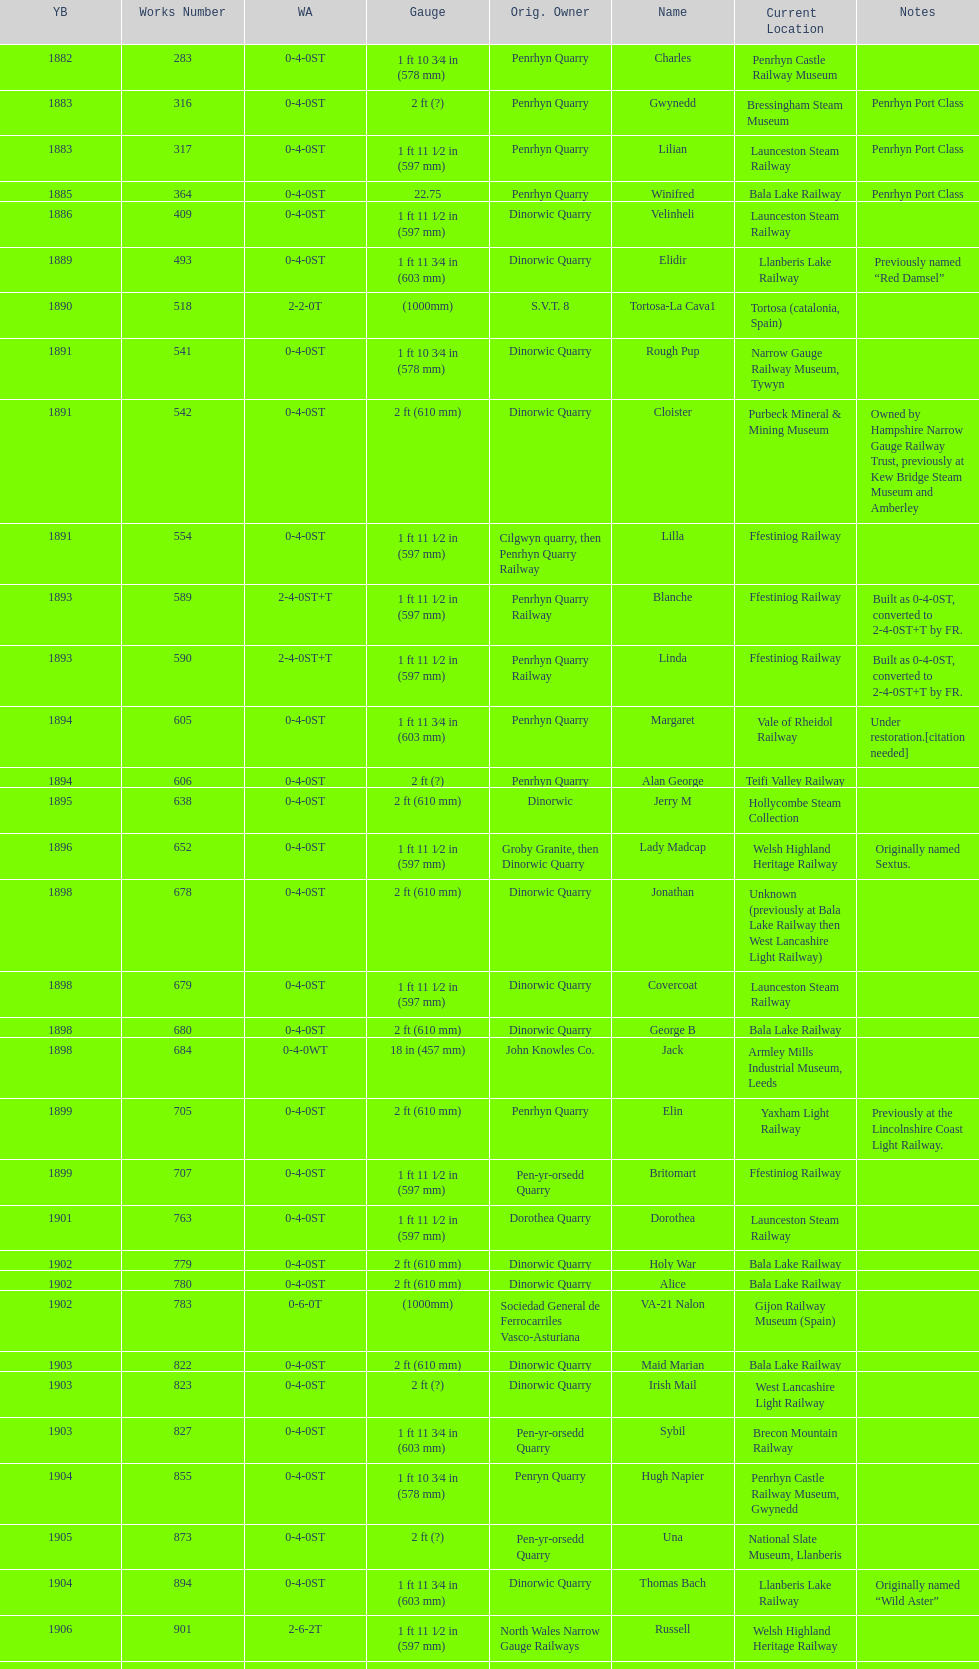Would you be able to parse every entry in this table? {'header': ['YB', 'Works Number', 'WA', 'Gauge', 'Orig. Owner', 'Name', 'Current Location', 'Notes'], 'rows': [['1882', '283', '0-4-0ST', '1\xa0ft 10\xa03⁄4\xa0in (578\xa0mm)', 'Penrhyn Quarry', 'Charles', 'Penrhyn Castle Railway Museum', ''], ['1883', '316', '0-4-0ST', '2\xa0ft (?)', 'Penrhyn Quarry', 'Gwynedd', 'Bressingham Steam Museum', 'Penrhyn Port Class'], ['1883', '317', '0-4-0ST', '1\xa0ft 11\xa01⁄2\xa0in (597\xa0mm)', 'Penrhyn Quarry', 'Lilian', 'Launceston Steam Railway', 'Penrhyn Port Class'], ['1885', '364', '0-4-0ST', '22.75', 'Penrhyn Quarry', 'Winifred', 'Bala Lake Railway', 'Penrhyn Port Class'], ['1886', '409', '0-4-0ST', '1\xa0ft 11\xa01⁄2\xa0in (597\xa0mm)', 'Dinorwic Quarry', 'Velinheli', 'Launceston Steam Railway', ''], ['1889', '493', '0-4-0ST', '1\xa0ft 11\xa03⁄4\xa0in (603\xa0mm)', 'Dinorwic Quarry', 'Elidir', 'Llanberis Lake Railway', 'Previously named “Red Damsel”'], ['1890', '518', '2-2-0T', '(1000mm)', 'S.V.T. 8', 'Tortosa-La Cava1', 'Tortosa (catalonia, Spain)', ''], ['1891', '541', '0-4-0ST', '1\xa0ft 10\xa03⁄4\xa0in (578\xa0mm)', 'Dinorwic Quarry', 'Rough Pup', 'Narrow Gauge Railway Museum, Tywyn', ''], ['1891', '542', '0-4-0ST', '2\xa0ft (610\xa0mm)', 'Dinorwic Quarry', 'Cloister', 'Purbeck Mineral & Mining Museum', 'Owned by Hampshire Narrow Gauge Railway Trust, previously at Kew Bridge Steam Museum and Amberley'], ['1891', '554', '0-4-0ST', '1\xa0ft 11\xa01⁄2\xa0in (597\xa0mm)', 'Cilgwyn quarry, then Penrhyn Quarry Railway', 'Lilla', 'Ffestiniog Railway', ''], ['1893', '589', '2-4-0ST+T', '1\xa0ft 11\xa01⁄2\xa0in (597\xa0mm)', 'Penrhyn Quarry Railway', 'Blanche', 'Ffestiniog Railway', 'Built as 0-4-0ST, converted to 2-4-0ST+T by FR.'], ['1893', '590', '2-4-0ST+T', '1\xa0ft 11\xa01⁄2\xa0in (597\xa0mm)', 'Penrhyn Quarry Railway', 'Linda', 'Ffestiniog Railway', 'Built as 0-4-0ST, converted to 2-4-0ST+T by FR.'], ['1894', '605', '0-4-0ST', '1\xa0ft 11\xa03⁄4\xa0in (603\xa0mm)', 'Penrhyn Quarry', 'Margaret', 'Vale of Rheidol Railway', 'Under restoration.[citation needed]'], ['1894', '606', '0-4-0ST', '2\xa0ft (?)', 'Penrhyn Quarry', 'Alan George', 'Teifi Valley Railway', ''], ['1895', '638', '0-4-0ST', '2\xa0ft (610\xa0mm)', 'Dinorwic', 'Jerry M', 'Hollycombe Steam Collection', ''], ['1896', '652', '0-4-0ST', '1\xa0ft 11\xa01⁄2\xa0in (597\xa0mm)', 'Groby Granite, then Dinorwic Quarry', 'Lady Madcap', 'Welsh Highland Heritage Railway', 'Originally named Sextus.'], ['1898', '678', '0-4-0ST', '2\xa0ft (610\xa0mm)', 'Dinorwic Quarry', 'Jonathan', 'Unknown (previously at Bala Lake Railway then West Lancashire Light Railway)', ''], ['1898', '679', '0-4-0ST', '1\xa0ft 11\xa01⁄2\xa0in (597\xa0mm)', 'Dinorwic Quarry', 'Covercoat', 'Launceston Steam Railway', ''], ['1898', '680', '0-4-0ST', '2\xa0ft (610\xa0mm)', 'Dinorwic Quarry', 'George B', 'Bala Lake Railway', ''], ['1898', '684', '0-4-0WT', '18\xa0in (457\xa0mm)', 'John Knowles Co.', 'Jack', 'Armley Mills Industrial Museum, Leeds', ''], ['1899', '705', '0-4-0ST', '2\xa0ft (610\xa0mm)', 'Penrhyn Quarry', 'Elin', 'Yaxham Light Railway', 'Previously at the Lincolnshire Coast Light Railway.'], ['1899', '707', '0-4-0ST', '1\xa0ft 11\xa01⁄2\xa0in (597\xa0mm)', 'Pen-yr-orsedd Quarry', 'Britomart', 'Ffestiniog Railway', ''], ['1901', '763', '0-4-0ST', '1\xa0ft 11\xa01⁄2\xa0in (597\xa0mm)', 'Dorothea Quarry', 'Dorothea', 'Launceston Steam Railway', ''], ['1902', '779', '0-4-0ST', '2\xa0ft (610\xa0mm)', 'Dinorwic Quarry', 'Holy War', 'Bala Lake Railway', ''], ['1902', '780', '0-4-0ST', '2\xa0ft (610\xa0mm)', 'Dinorwic Quarry', 'Alice', 'Bala Lake Railway', ''], ['1902', '783', '0-6-0T', '(1000mm)', 'Sociedad General de Ferrocarriles Vasco-Asturiana', 'VA-21 Nalon', 'Gijon Railway Museum (Spain)', ''], ['1903', '822', '0-4-0ST', '2\xa0ft (610\xa0mm)', 'Dinorwic Quarry', 'Maid Marian', 'Bala Lake Railway', ''], ['1903', '823', '0-4-0ST', '2\xa0ft (?)', 'Dinorwic Quarry', 'Irish Mail', 'West Lancashire Light Railway', ''], ['1903', '827', '0-4-0ST', '1\xa0ft 11\xa03⁄4\xa0in (603\xa0mm)', 'Pen-yr-orsedd Quarry', 'Sybil', 'Brecon Mountain Railway', ''], ['1904', '855', '0-4-0ST', '1\xa0ft 10\xa03⁄4\xa0in (578\xa0mm)', 'Penryn Quarry', 'Hugh Napier', 'Penrhyn Castle Railway Museum, Gwynedd', ''], ['1905', '873', '0-4-0ST', '2\xa0ft (?)', 'Pen-yr-orsedd Quarry', 'Una', 'National Slate Museum, Llanberis', ''], ['1904', '894', '0-4-0ST', '1\xa0ft 11\xa03⁄4\xa0in (603\xa0mm)', 'Dinorwic Quarry', 'Thomas Bach', 'Llanberis Lake Railway', 'Originally named “Wild Aster”'], ['1906', '901', '2-6-2T', '1\xa0ft 11\xa01⁄2\xa0in (597\xa0mm)', 'North Wales Narrow Gauge Railways', 'Russell', 'Welsh Highland Heritage Railway', ''], ['1906', '920', '0-4-0ST', '2\xa0ft (?)', 'Penrhyn Quarry', 'Pamela', 'Old Kiln Light Railway', ''], ['1909', '994', '0-4-0ST', '2\xa0ft (?)', 'Penrhyn Quarry', 'Bill Harvey', 'Bressingham Steam Museum', 'previously George Sholto'], ['1918', '1312', '4-6-0T', '1\xa0ft\xa011\xa01⁄2\xa0in (597\xa0mm)', 'British War Department\\nEFOP #203', '---', 'Pampas Safari, Gravataí, RS, Brazil', '[citation needed]'], ['1918\\nor\\n1921?', '1313', '0-6-2T', '3\xa0ft\xa03\xa03⁄8\xa0in (1,000\xa0mm)', 'British War Department\\nUsina Leão Utinga #1\\nUsina Laginha #1', '---', 'Usina Laginha, União dos Palmares, AL, Brazil', '[citation needed]'], ['1920', '1404', '0-4-0WT', '18\xa0in (457\xa0mm)', 'John Knowles Co.', 'Gwen', 'Richard Farmer current owner, Northridge, California, USA', ''], ['1922', '1429', '0-4-0ST', '2\xa0ft (610\xa0mm)', 'Dinorwic', 'Lady Joan', 'Bredgar and Wormshill Light Railway', ''], ['1922', '1430', '0-4-0ST', '1\xa0ft 11\xa03⁄4\xa0in (603\xa0mm)', 'Dinorwic Quarry', 'Dolbadarn', 'Llanberis Lake Railway', ''], ['1937', '1859', '0-4-2T', '2\xa0ft (?)', 'Umtwalumi Valley Estate, Natal', '16 Carlisle', 'South Tynedale Railway', ''], ['1940', '2075', '0-4-2T', '2\xa0ft (?)', 'Chaka’s Kraal Sugar Estates, Natal', 'Chaka’s Kraal No. 6', 'North Gloucestershire Railway', ''], ['1954', '3815', '2-6-2T', '2\xa0ft 6\xa0in (762\xa0mm)', 'Sierra Leone Government Railway', '14', 'Welshpool and Llanfair Light Railway', ''], ['1971', '3902', '0-4-2ST', '2\xa0ft (610\xa0mm)', 'Trangkil Sugar Mill, Indonesia', 'Trangkil No.4', 'Statfold Barn Railway', 'Converted from 750\xa0mm (2\xa0ft\xa05\xa01⁄2\xa0in) gauge. Last steam locomotive to be built by Hunslet, and the last industrial steam locomotive built in Britain.']]} In which year were the most steam locomotives built? 1898. 